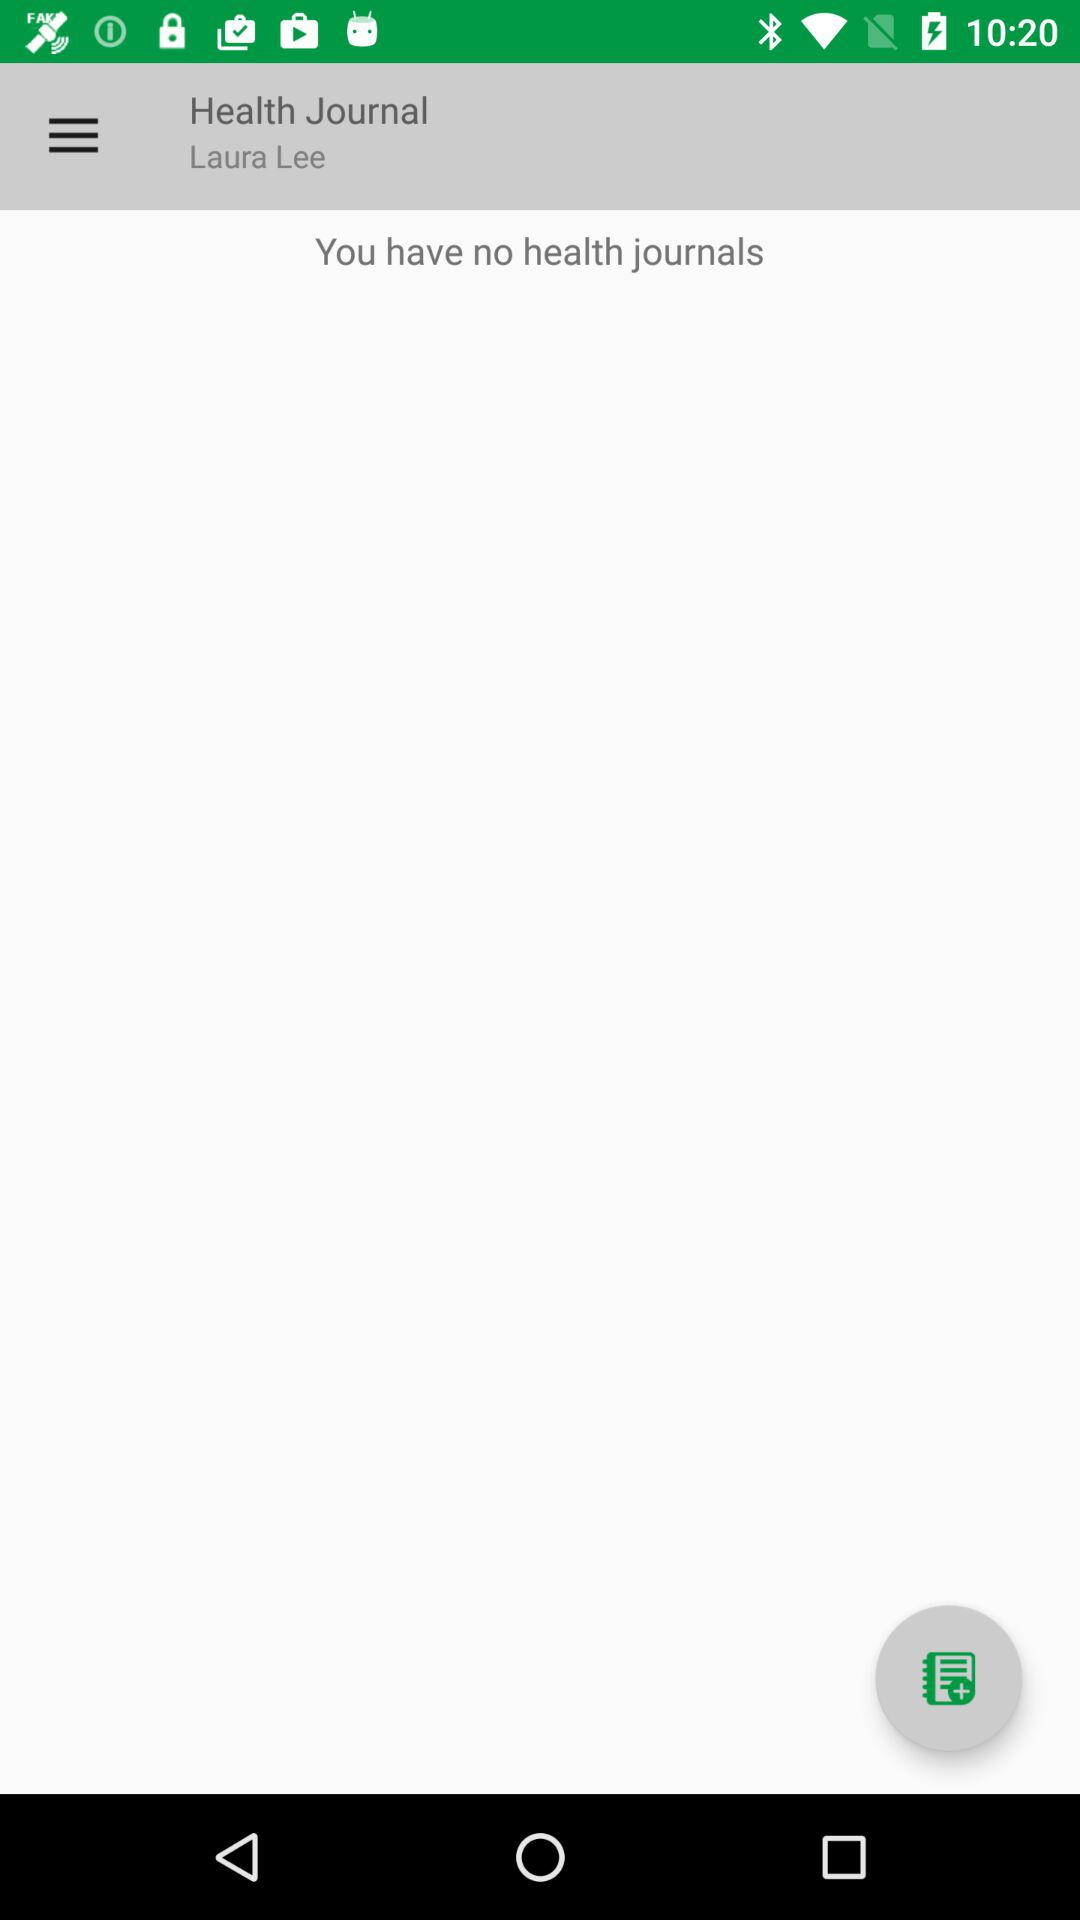How many health journals does Laura Lee have?
Answer the question using a single word or phrase. 0 